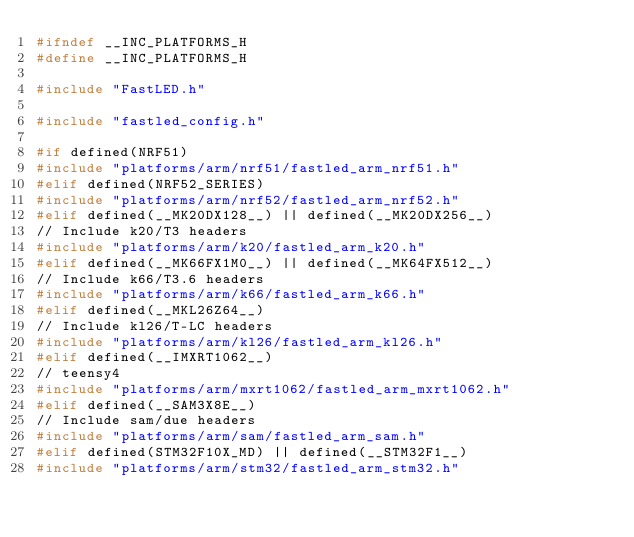<code> <loc_0><loc_0><loc_500><loc_500><_C_>#ifndef __INC_PLATFORMS_H
#define __INC_PLATFORMS_H

#include "FastLED.h"

#include "fastled_config.h"

#if defined(NRF51)
#include "platforms/arm/nrf51/fastled_arm_nrf51.h"
#elif defined(NRF52_SERIES)
#include "platforms/arm/nrf52/fastled_arm_nrf52.h"
#elif defined(__MK20DX128__) || defined(__MK20DX256__)
// Include k20/T3 headers
#include "platforms/arm/k20/fastled_arm_k20.h"
#elif defined(__MK66FX1M0__) || defined(__MK64FX512__)
// Include k66/T3.6 headers
#include "platforms/arm/k66/fastled_arm_k66.h"
#elif defined(__MKL26Z64__)
// Include kl26/T-LC headers
#include "platforms/arm/kl26/fastled_arm_kl26.h"
#elif defined(__IMXRT1062__)
// teensy4
#include "platforms/arm/mxrt1062/fastled_arm_mxrt1062.h"
#elif defined(__SAM3X8E__)
// Include sam/due headers
#include "platforms/arm/sam/fastled_arm_sam.h"
#elif defined(STM32F10X_MD) || defined(__STM32F1__)
#include "platforms/arm/stm32/fastled_arm_stm32.h"</code> 